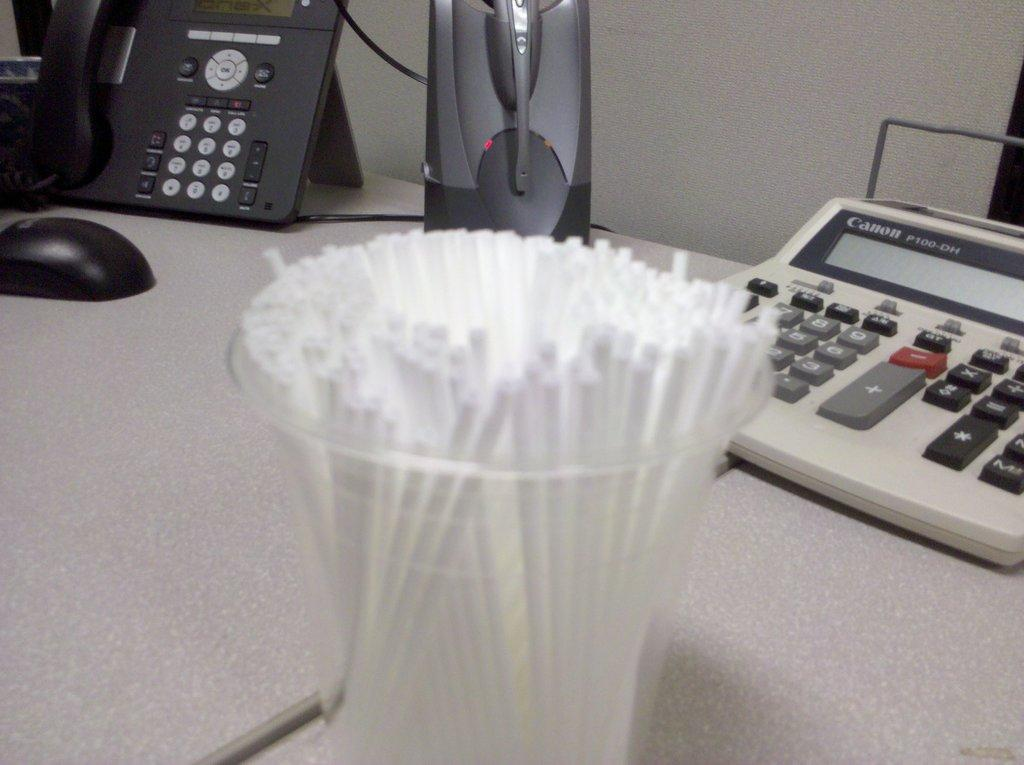Provide a one-sentence caption for the provided image. a calculator on the right made by Canon. 